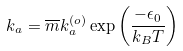<formula> <loc_0><loc_0><loc_500><loc_500>k _ { a } = \overline { m } k _ { a } ^ { ( o ) } \exp \left ( \frac { - \epsilon _ { 0 } } { k _ { B } T } \right )</formula> 